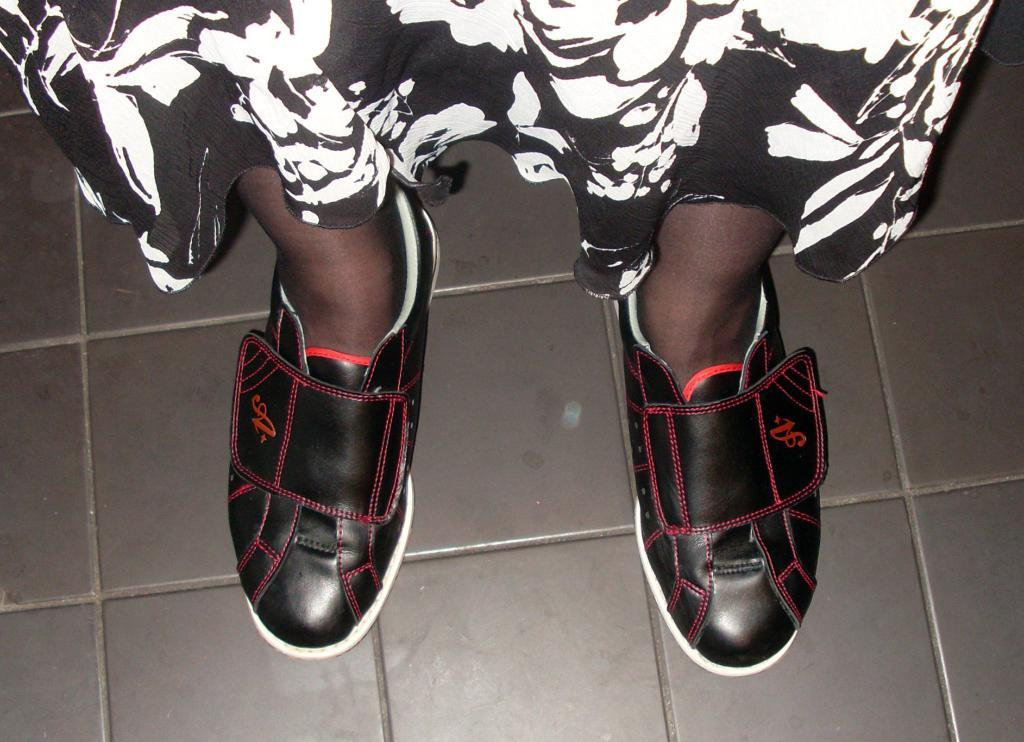What body part can be seen in the image? There are legs visible in the image. What type of footwear is the person wearing? The person is wearing shoes. What is the surface beneath the person in the image? There is a floor in the background of the image. How many parcels is the manager holding in the image? There is no manager or parcel present in the image. 